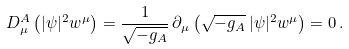Convert formula to latex. <formula><loc_0><loc_0><loc_500><loc_500>D ^ { A } _ { \mu } \left ( | \psi | ^ { 2 } w ^ { \mu } \right ) = \frac { 1 } { \sqrt { - g _ { A } } } \, \partial _ { \mu } \left ( \sqrt { - g _ { A } } \, | \psi | ^ { 2 } w ^ { \mu } \right ) = 0 \, .</formula> 